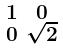<formula> <loc_0><loc_0><loc_500><loc_500>\begin{smallmatrix} 1 & 0 \\ 0 & \sqrt { 2 } \end{smallmatrix}</formula> 